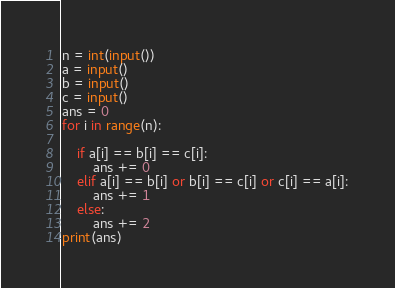<code> <loc_0><loc_0><loc_500><loc_500><_Python_>n = int(input())
a = input()
b = input()
c = input()
ans = 0
for i in range(n):
    
    if a[i] == b[i] == c[i]:
        ans += 0
    elif a[i] == b[i] or b[i] == c[i] or c[i] == a[i]:
        ans += 1
    else:
        ans += 2
print(ans)
</code> 